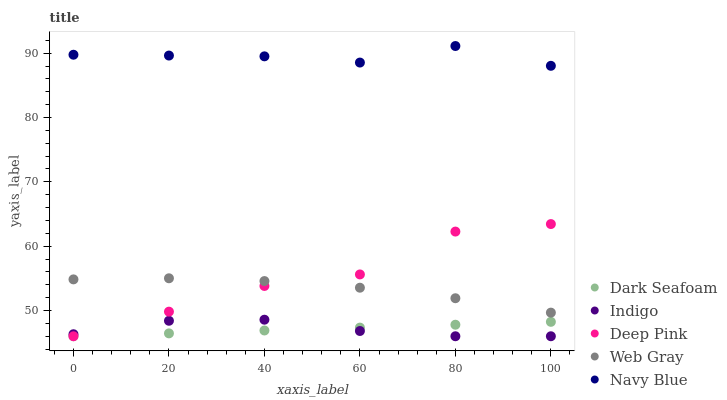Does Dark Seafoam have the minimum area under the curve?
Answer yes or no. Yes. Does Navy Blue have the maximum area under the curve?
Answer yes or no. Yes. Does Navy Blue have the minimum area under the curve?
Answer yes or no. No. Does Dark Seafoam have the maximum area under the curve?
Answer yes or no. No. Is Dark Seafoam the smoothest?
Answer yes or no. Yes. Is Deep Pink the roughest?
Answer yes or no. Yes. Is Navy Blue the smoothest?
Answer yes or no. No. Is Navy Blue the roughest?
Answer yes or no. No. Does Dark Seafoam have the lowest value?
Answer yes or no. Yes. Does Navy Blue have the lowest value?
Answer yes or no. No. Does Navy Blue have the highest value?
Answer yes or no. Yes. Does Dark Seafoam have the highest value?
Answer yes or no. No. Is Dark Seafoam less than Web Gray?
Answer yes or no. Yes. Is Navy Blue greater than Dark Seafoam?
Answer yes or no. Yes. Does Dark Seafoam intersect Indigo?
Answer yes or no. Yes. Is Dark Seafoam less than Indigo?
Answer yes or no. No. Is Dark Seafoam greater than Indigo?
Answer yes or no. No. Does Dark Seafoam intersect Web Gray?
Answer yes or no. No. 